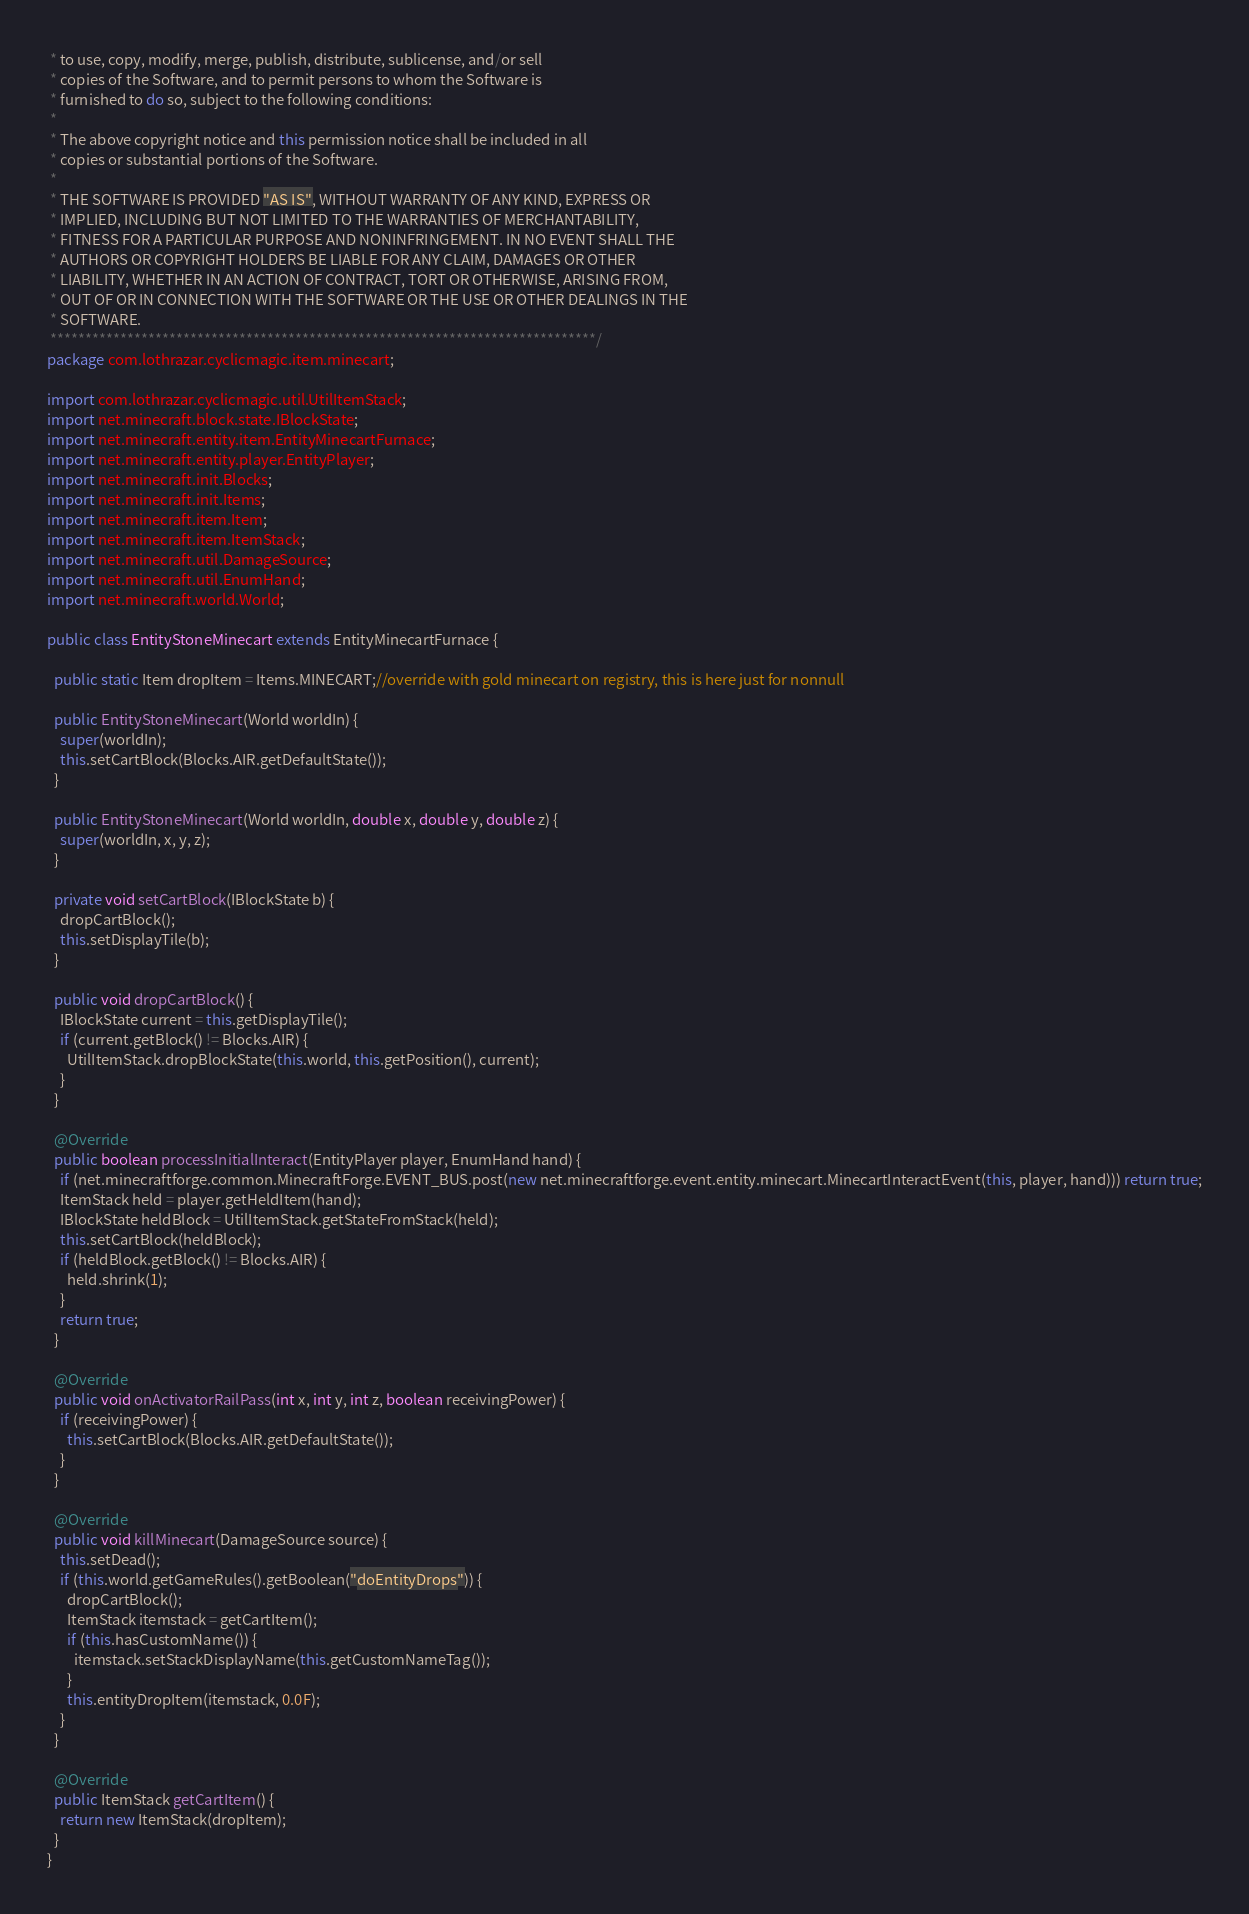<code> <loc_0><loc_0><loc_500><loc_500><_Java_> * to use, copy, modify, merge, publish, distribute, sublicense, and/or sell
 * copies of the Software, and to permit persons to whom the Software is
 * furnished to do so, subject to the following conditions:
 * 
 * The above copyright notice and this permission notice shall be included in all
 * copies or substantial portions of the Software.
 * 
 * THE SOFTWARE IS PROVIDED "AS IS", WITHOUT WARRANTY OF ANY KIND, EXPRESS OR
 * IMPLIED, INCLUDING BUT NOT LIMITED TO THE WARRANTIES OF MERCHANTABILITY,
 * FITNESS FOR A PARTICULAR PURPOSE AND NONINFRINGEMENT. IN NO EVENT SHALL THE
 * AUTHORS OR COPYRIGHT HOLDERS BE LIABLE FOR ANY CLAIM, DAMAGES OR OTHER
 * LIABILITY, WHETHER IN AN ACTION OF CONTRACT, TORT OR OTHERWISE, ARISING FROM,
 * OUT OF OR IN CONNECTION WITH THE SOFTWARE OR THE USE OR OTHER DEALINGS IN THE
 * SOFTWARE.
 ******************************************************************************/
package com.lothrazar.cyclicmagic.item.minecart;

import com.lothrazar.cyclicmagic.util.UtilItemStack;
import net.minecraft.block.state.IBlockState;
import net.minecraft.entity.item.EntityMinecartFurnace;
import net.minecraft.entity.player.EntityPlayer;
import net.minecraft.init.Blocks;
import net.minecraft.init.Items;
import net.minecraft.item.Item;
import net.minecraft.item.ItemStack;
import net.minecraft.util.DamageSource;
import net.minecraft.util.EnumHand;
import net.minecraft.world.World;

public class EntityStoneMinecart extends EntityMinecartFurnace {

  public static Item dropItem = Items.MINECART;//override with gold minecart on registry, this is here just for nonnull

  public EntityStoneMinecart(World worldIn) {
    super(worldIn);
    this.setCartBlock(Blocks.AIR.getDefaultState());
  }

  public EntityStoneMinecart(World worldIn, double x, double y, double z) {
    super(worldIn, x, y, z);
  }

  private void setCartBlock(IBlockState b) {
    dropCartBlock();
    this.setDisplayTile(b);
  }

  public void dropCartBlock() {
    IBlockState current = this.getDisplayTile();
    if (current.getBlock() != Blocks.AIR) {
      UtilItemStack.dropBlockState(this.world, this.getPosition(), current);
    }
  }

  @Override
  public boolean processInitialInteract(EntityPlayer player, EnumHand hand) {
    if (net.minecraftforge.common.MinecraftForge.EVENT_BUS.post(new net.minecraftforge.event.entity.minecart.MinecartInteractEvent(this, player, hand))) return true;
    ItemStack held = player.getHeldItem(hand);
    IBlockState heldBlock = UtilItemStack.getStateFromStack(held);
    this.setCartBlock(heldBlock);
    if (heldBlock.getBlock() != Blocks.AIR) {
      held.shrink(1);
    }
    return true;
  }

  @Override
  public void onActivatorRailPass(int x, int y, int z, boolean receivingPower) {
    if (receivingPower) {
      this.setCartBlock(Blocks.AIR.getDefaultState());
    }
  }

  @Override
  public void killMinecart(DamageSource source) {
    this.setDead();
    if (this.world.getGameRules().getBoolean("doEntityDrops")) {
      dropCartBlock();
      ItemStack itemstack = getCartItem();
      if (this.hasCustomName()) {
        itemstack.setStackDisplayName(this.getCustomNameTag());
      }
      this.entityDropItem(itemstack, 0.0F);
    }
  }

  @Override
  public ItemStack getCartItem() {
    return new ItemStack(dropItem);
  }
}
</code> 